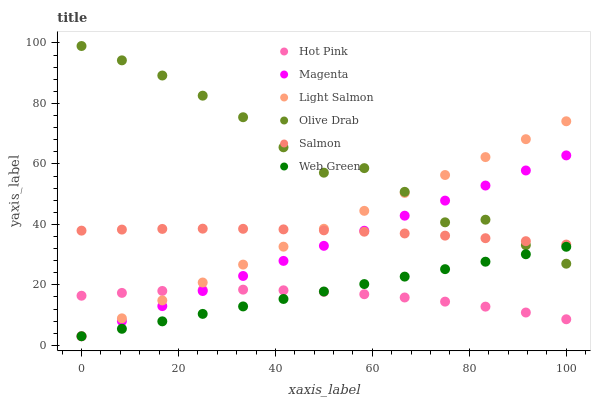Does Hot Pink have the minimum area under the curve?
Answer yes or no. Yes. Does Olive Drab have the maximum area under the curve?
Answer yes or no. Yes. Does Salmon have the minimum area under the curve?
Answer yes or no. No. Does Salmon have the maximum area under the curve?
Answer yes or no. No. Is Web Green the smoothest?
Answer yes or no. Yes. Is Olive Drab the roughest?
Answer yes or no. Yes. Is Hot Pink the smoothest?
Answer yes or no. No. Is Hot Pink the roughest?
Answer yes or no. No. Does Light Salmon have the lowest value?
Answer yes or no. Yes. Does Hot Pink have the lowest value?
Answer yes or no. No. Does Olive Drab have the highest value?
Answer yes or no. Yes. Does Salmon have the highest value?
Answer yes or no. No. Is Hot Pink less than Olive Drab?
Answer yes or no. Yes. Is Olive Drab greater than Hot Pink?
Answer yes or no. Yes. Does Olive Drab intersect Web Green?
Answer yes or no. Yes. Is Olive Drab less than Web Green?
Answer yes or no. No. Is Olive Drab greater than Web Green?
Answer yes or no. No. Does Hot Pink intersect Olive Drab?
Answer yes or no. No. 